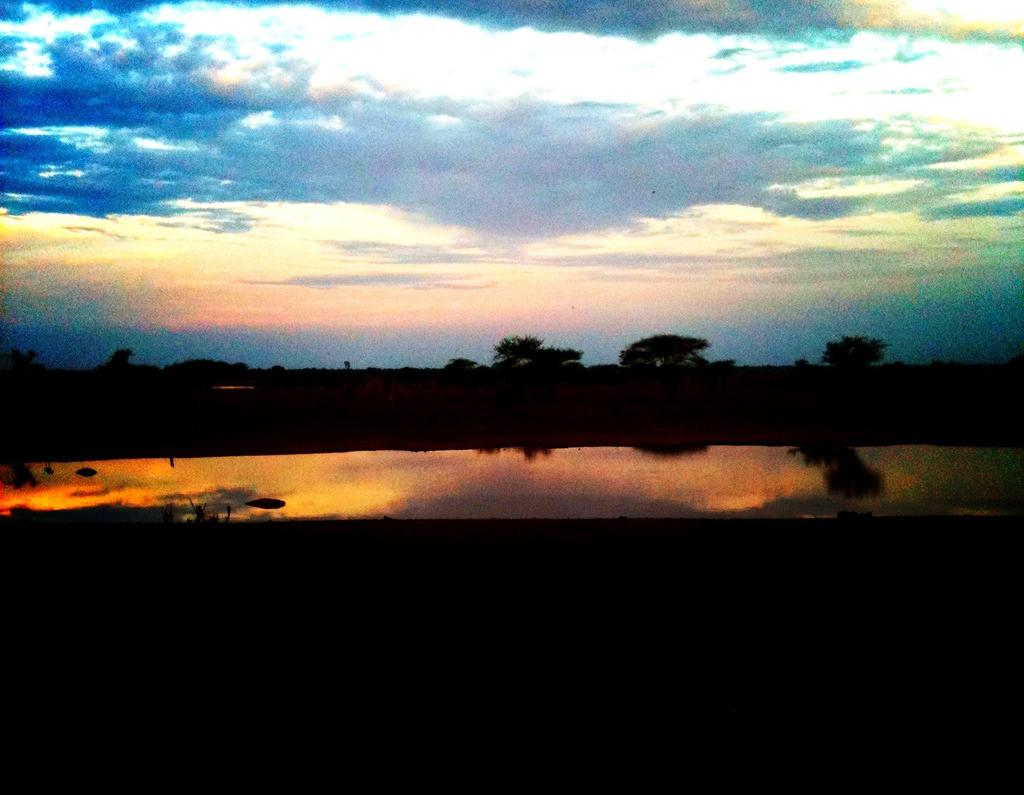What is visible in the foreground of the image? There is water in the foreground of the image. What can be seen in the background of the image? There are trees in the background of the image. How would you describe the sky in the image? The sky is cloudy in the image. Can you see a knot tied in one of the tree branches in the image? There is no mention of a knot or any specific details about the trees in the image, so it cannot be determined if a knot is present. Is there a ball being thrown in the water in the image? There is no ball or any indication of activity involving a ball in the image. 